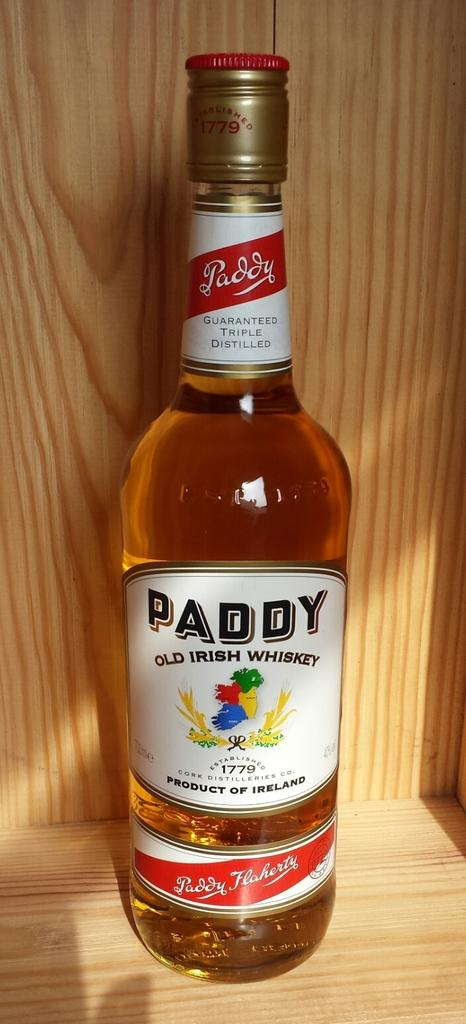<image>
Relay a brief, clear account of the picture shown. A bottle of whiskey with a white label that says Paddy Old Irish Whiskey. 